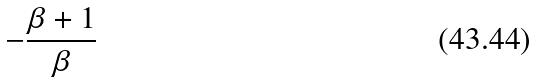<formula> <loc_0><loc_0><loc_500><loc_500>- \frac { \beta + 1 } { \beta }</formula> 